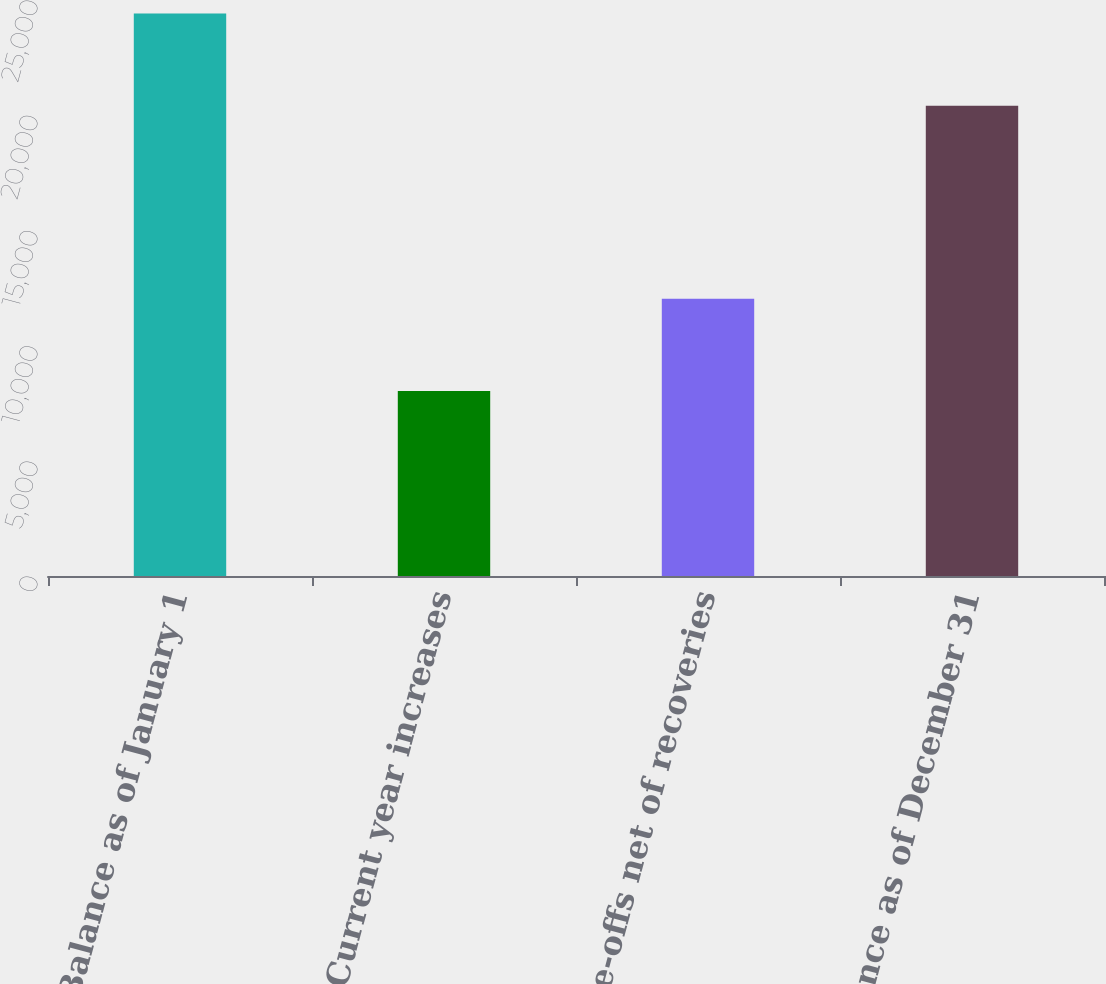<chart> <loc_0><loc_0><loc_500><loc_500><bar_chart><fcel>Balance as of January 1<fcel>Current year increases<fcel>Write-offs net of recoveries<fcel>Balance as of December 31<nl><fcel>24412<fcel>8028<fcel>12034<fcel>20406<nl></chart> 